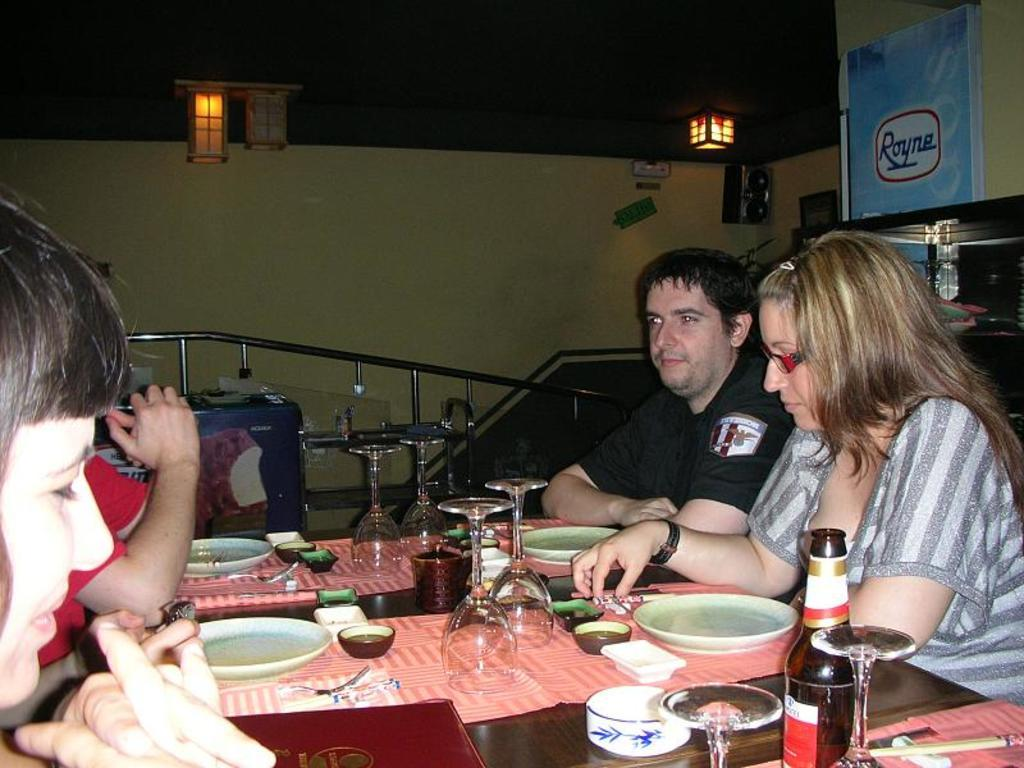How many people are sitting around the table in the image? There are four people sitting around the table in the image. What is on the table? There is a mat, glasses, plates, bowls, and a menu card on the table. What can be seen in the background of the image? There is a wall in the background. What is the source of light in the image? There are lights in the ceiling. How long does it take for the note to exchange hands in the image? There is no note or exchange of any kind present in the image. 